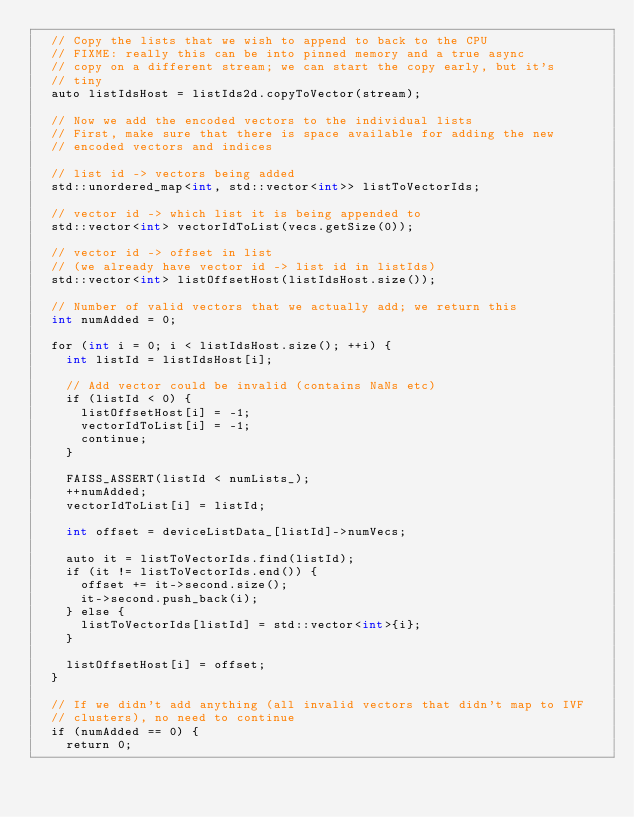<code> <loc_0><loc_0><loc_500><loc_500><_Cuda_>  // Copy the lists that we wish to append to back to the CPU
  // FIXME: really this can be into pinned memory and a true async
  // copy on a different stream; we can start the copy early, but it's
  // tiny
  auto listIdsHost = listIds2d.copyToVector(stream);

  // Now we add the encoded vectors to the individual lists
  // First, make sure that there is space available for adding the new
  // encoded vectors and indices

  // list id -> vectors being added
  std::unordered_map<int, std::vector<int>> listToVectorIds;

  // vector id -> which list it is being appended to
  std::vector<int> vectorIdToList(vecs.getSize(0));

  // vector id -> offset in list
  // (we already have vector id -> list id in listIds)
  std::vector<int> listOffsetHost(listIdsHost.size());

  // Number of valid vectors that we actually add; we return this
  int numAdded = 0;

  for (int i = 0; i < listIdsHost.size(); ++i) {
    int listId = listIdsHost[i];

    // Add vector could be invalid (contains NaNs etc)
    if (listId < 0) {
      listOffsetHost[i] = -1;
      vectorIdToList[i] = -1;
      continue;
    }

    FAISS_ASSERT(listId < numLists_);
    ++numAdded;
    vectorIdToList[i] = listId;

    int offset = deviceListData_[listId]->numVecs;

    auto it = listToVectorIds.find(listId);
    if (it != listToVectorIds.end()) {
      offset += it->second.size();
      it->second.push_back(i);
    } else {
      listToVectorIds[listId] = std::vector<int>{i};
    }

    listOffsetHost[i] = offset;
  }

  // If we didn't add anything (all invalid vectors that didn't map to IVF
  // clusters), no need to continue
  if (numAdded == 0) {
    return 0;</code> 